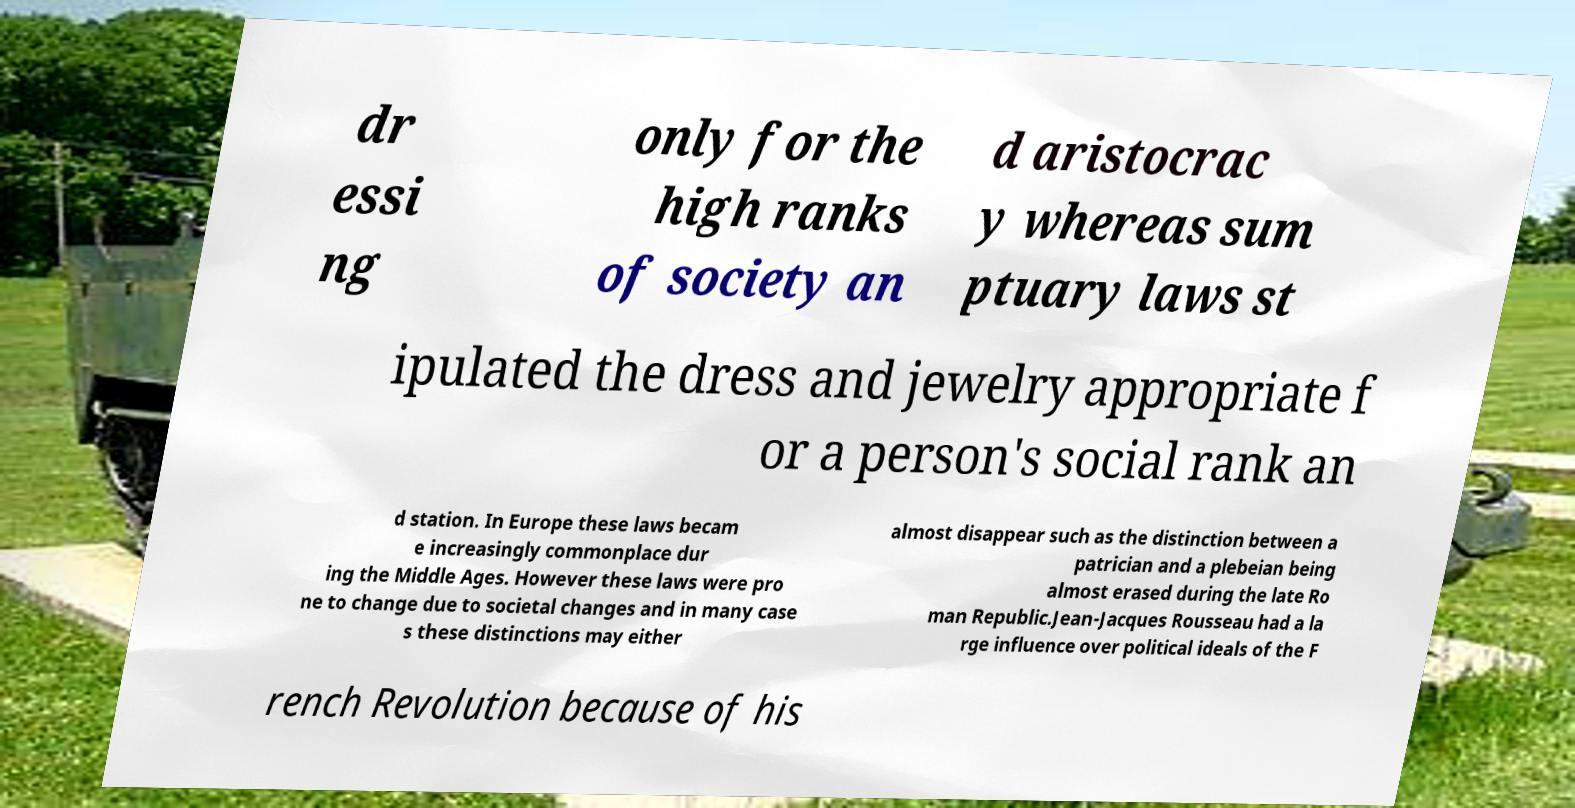Could you extract and type out the text from this image? dr essi ng only for the high ranks of society an d aristocrac y whereas sum ptuary laws st ipulated the dress and jewelry appropriate f or a person's social rank an d station. In Europe these laws becam e increasingly commonplace dur ing the Middle Ages. However these laws were pro ne to change due to societal changes and in many case s these distinctions may either almost disappear such as the distinction between a patrician and a plebeian being almost erased during the late Ro man Republic.Jean-Jacques Rousseau had a la rge influence over political ideals of the F rench Revolution because of his 